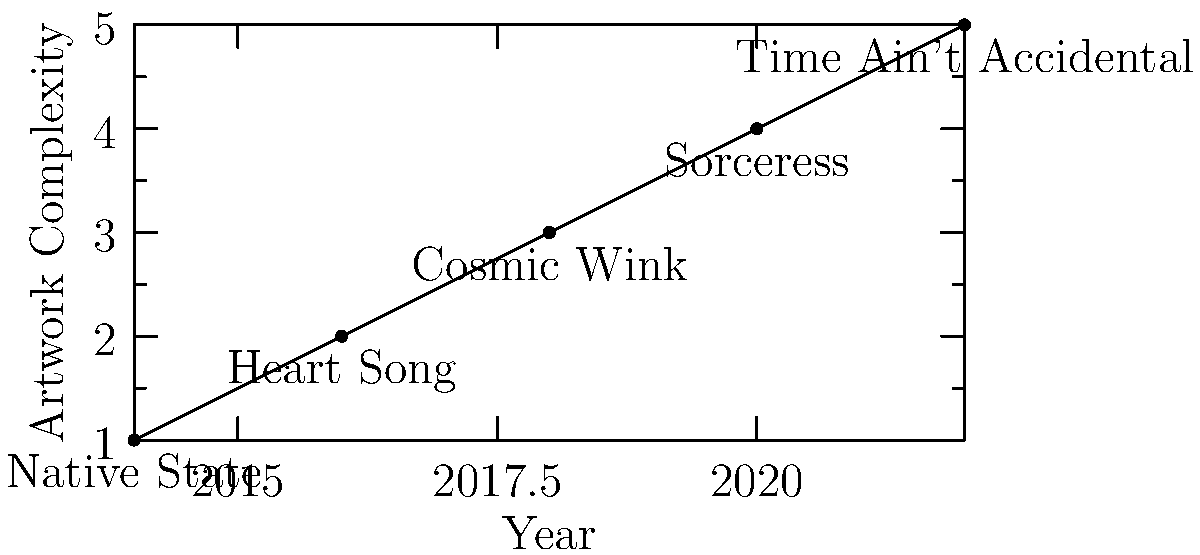Based on the graph showing the evolution of Jess Williamson's album artwork complexity over time, which album marked a significant leap in visual intricacy compared to its predecessor? To answer this question, we need to analyze the graph step-by-step:

1. The graph shows Jess Williamson's albums from 2014 to 2022 on the x-axis.
2. The y-axis represents the complexity of the album artwork, with higher values indicating more complex designs.
3. We need to look for the largest vertical jump between consecutive albums:

   - Native State (2014) to Heart Song (2016): Small increase
   - Heart Song (2016) to Cosmic Wink (2018): Moderate increase
   - Cosmic Wink (2018) to Sorceress (2020): Largest increase
   - Sorceress (2020) to Time Ain't Accidental (2022): Small increase

4. The most significant leap in complexity occurs between Cosmic Wink (2018) and Sorceress (2020).
Answer: Sorceress 